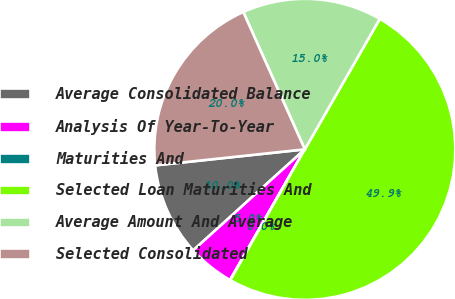<chart> <loc_0><loc_0><loc_500><loc_500><pie_chart><fcel>Average Consolidated Balance<fcel>Analysis Of Year-To-Year<fcel>Maturities And<fcel>Selected Loan Maturities And<fcel>Average Amount And Average<fcel>Selected Consolidated<nl><fcel>10.01%<fcel>5.02%<fcel>0.03%<fcel>49.93%<fcel>15.0%<fcel>19.99%<nl></chart> 